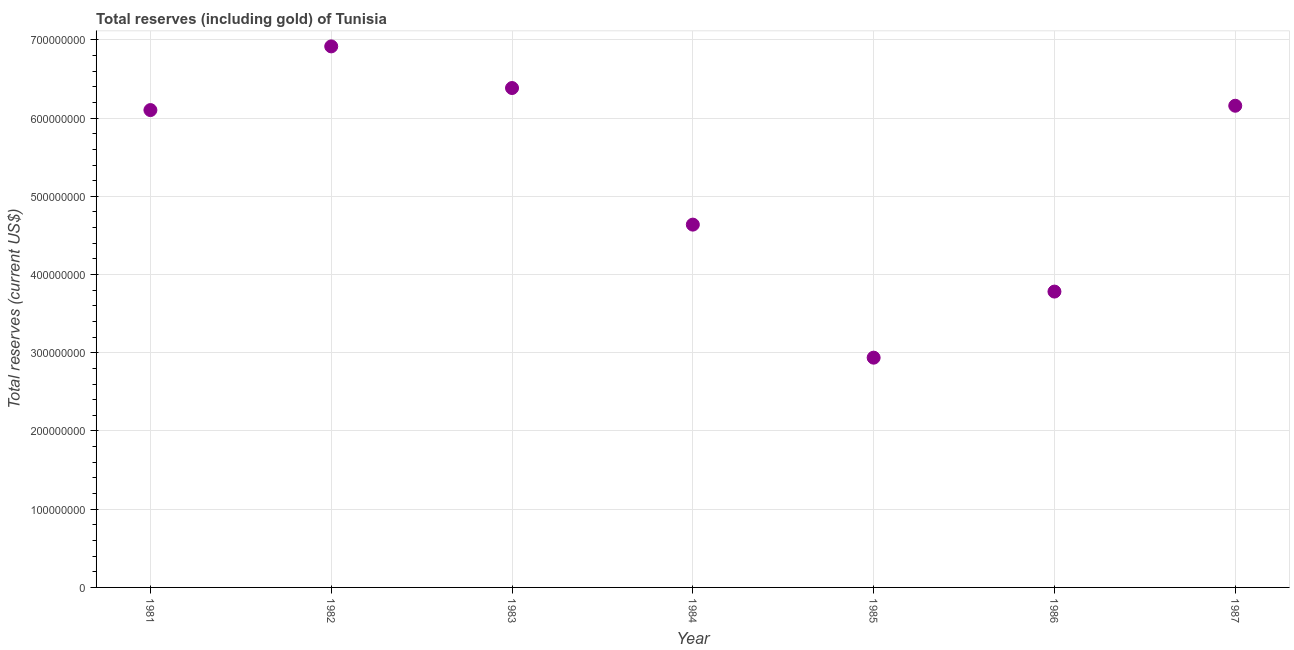What is the total reserves (including gold) in 1986?
Your answer should be very brief. 3.78e+08. Across all years, what is the maximum total reserves (including gold)?
Your answer should be compact. 6.92e+08. Across all years, what is the minimum total reserves (including gold)?
Give a very brief answer. 2.94e+08. In which year was the total reserves (including gold) maximum?
Give a very brief answer. 1982. What is the sum of the total reserves (including gold)?
Make the answer very short. 3.69e+09. What is the difference between the total reserves (including gold) in 1983 and 1987?
Keep it short and to the point. 2.26e+07. What is the average total reserves (including gold) per year?
Offer a very short reply. 5.27e+08. What is the median total reserves (including gold)?
Give a very brief answer. 6.10e+08. What is the ratio of the total reserves (including gold) in 1981 to that in 1983?
Your answer should be compact. 0.96. Is the total reserves (including gold) in 1981 less than that in 1985?
Offer a terse response. No. What is the difference between the highest and the second highest total reserves (including gold)?
Provide a succinct answer. 5.32e+07. Is the sum of the total reserves (including gold) in 1984 and 1986 greater than the maximum total reserves (including gold) across all years?
Offer a very short reply. Yes. What is the difference between the highest and the lowest total reserves (including gold)?
Offer a terse response. 3.98e+08. In how many years, is the total reserves (including gold) greater than the average total reserves (including gold) taken over all years?
Give a very brief answer. 4. How many dotlines are there?
Give a very brief answer. 1. How many years are there in the graph?
Give a very brief answer. 7. What is the difference between two consecutive major ticks on the Y-axis?
Provide a succinct answer. 1.00e+08. Does the graph contain grids?
Give a very brief answer. Yes. What is the title of the graph?
Your answer should be compact. Total reserves (including gold) of Tunisia. What is the label or title of the Y-axis?
Keep it short and to the point. Total reserves (current US$). What is the Total reserves (current US$) in 1981?
Make the answer very short. 6.10e+08. What is the Total reserves (current US$) in 1982?
Provide a succinct answer. 6.92e+08. What is the Total reserves (current US$) in 1983?
Offer a very short reply. 6.38e+08. What is the Total reserves (current US$) in 1984?
Keep it short and to the point. 4.64e+08. What is the Total reserves (current US$) in 1985?
Ensure brevity in your answer.  2.94e+08. What is the Total reserves (current US$) in 1986?
Provide a succinct answer. 3.78e+08. What is the Total reserves (current US$) in 1987?
Keep it short and to the point. 6.16e+08. What is the difference between the Total reserves (current US$) in 1981 and 1982?
Provide a short and direct response. -8.14e+07. What is the difference between the Total reserves (current US$) in 1981 and 1983?
Provide a short and direct response. -2.82e+07. What is the difference between the Total reserves (current US$) in 1981 and 1984?
Your answer should be compact. 1.46e+08. What is the difference between the Total reserves (current US$) in 1981 and 1985?
Ensure brevity in your answer.  3.17e+08. What is the difference between the Total reserves (current US$) in 1981 and 1986?
Your answer should be compact. 2.32e+08. What is the difference between the Total reserves (current US$) in 1981 and 1987?
Provide a succinct answer. -5.54e+06. What is the difference between the Total reserves (current US$) in 1982 and 1983?
Make the answer very short. 5.32e+07. What is the difference between the Total reserves (current US$) in 1982 and 1984?
Give a very brief answer. 2.28e+08. What is the difference between the Total reserves (current US$) in 1982 and 1985?
Your answer should be compact. 3.98e+08. What is the difference between the Total reserves (current US$) in 1982 and 1986?
Offer a very short reply. 3.13e+08. What is the difference between the Total reserves (current US$) in 1982 and 1987?
Offer a terse response. 7.59e+07. What is the difference between the Total reserves (current US$) in 1983 and 1984?
Provide a short and direct response. 1.75e+08. What is the difference between the Total reserves (current US$) in 1983 and 1985?
Your answer should be very brief. 3.45e+08. What is the difference between the Total reserves (current US$) in 1983 and 1986?
Your answer should be compact. 2.60e+08. What is the difference between the Total reserves (current US$) in 1983 and 1987?
Keep it short and to the point. 2.26e+07. What is the difference between the Total reserves (current US$) in 1984 and 1985?
Ensure brevity in your answer.  1.70e+08. What is the difference between the Total reserves (current US$) in 1984 and 1986?
Keep it short and to the point. 8.56e+07. What is the difference between the Total reserves (current US$) in 1984 and 1987?
Your response must be concise. -1.52e+08. What is the difference between the Total reserves (current US$) in 1985 and 1986?
Keep it short and to the point. -8.45e+07. What is the difference between the Total reserves (current US$) in 1985 and 1987?
Keep it short and to the point. -3.22e+08. What is the difference between the Total reserves (current US$) in 1986 and 1987?
Offer a terse response. -2.38e+08. What is the ratio of the Total reserves (current US$) in 1981 to that in 1982?
Offer a very short reply. 0.88. What is the ratio of the Total reserves (current US$) in 1981 to that in 1983?
Offer a terse response. 0.96. What is the ratio of the Total reserves (current US$) in 1981 to that in 1984?
Your answer should be very brief. 1.32. What is the ratio of the Total reserves (current US$) in 1981 to that in 1985?
Your response must be concise. 2.08. What is the ratio of the Total reserves (current US$) in 1981 to that in 1986?
Your response must be concise. 1.61. What is the ratio of the Total reserves (current US$) in 1982 to that in 1983?
Offer a terse response. 1.08. What is the ratio of the Total reserves (current US$) in 1982 to that in 1984?
Keep it short and to the point. 1.49. What is the ratio of the Total reserves (current US$) in 1982 to that in 1985?
Your response must be concise. 2.35. What is the ratio of the Total reserves (current US$) in 1982 to that in 1986?
Offer a terse response. 1.83. What is the ratio of the Total reserves (current US$) in 1982 to that in 1987?
Offer a terse response. 1.12. What is the ratio of the Total reserves (current US$) in 1983 to that in 1984?
Keep it short and to the point. 1.38. What is the ratio of the Total reserves (current US$) in 1983 to that in 1985?
Your answer should be compact. 2.17. What is the ratio of the Total reserves (current US$) in 1983 to that in 1986?
Make the answer very short. 1.69. What is the ratio of the Total reserves (current US$) in 1984 to that in 1985?
Offer a very short reply. 1.58. What is the ratio of the Total reserves (current US$) in 1984 to that in 1986?
Your answer should be very brief. 1.23. What is the ratio of the Total reserves (current US$) in 1984 to that in 1987?
Your answer should be compact. 0.75. What is the ratio of the Total reserves (current US$) in 1985 to that in 1986?
Offer a terse response. 0.78. What is the ratio of the Total reserves (current US$) in 1985 to that in 1987?
Ensure brevity in your answer.  0.48. What is the ratio of the Total reserves (current US$) in 1986 to that in 1987?
Give a very brief answer. 0.61. 